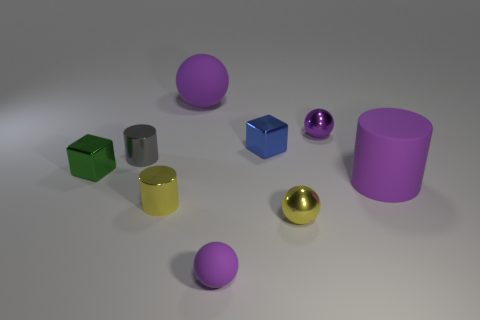Are there more tiny purple balls behind the yellow ball than small blue rubber cylinders?
Your answer should be compact. Yes. Is there another tiny metal object of the same shape as the gray metallic thing?
Make the answer very short. Yes. Do the blue object and the tiny cube on the left side of the big purple rubber sphere have the same material?
Make the answer very short. Yes. The tiny rubber object has what color?
Your response must be concise. Purple. How many small metal cylinders are on the right side of the small purple ball in front of the metallic ball that is behind the big rubber cylinder?
Ensure brevity in your answer.  0. There is a rubber cylinder; are there any purple spheres left of it?
Your answer should be compact. Yes. What number of large purple balls are the same material as the purple cylinder?
Keep it short and to the point. 1. What number of objects are either yellow metallic objects or big matte objects?
Make the answer very short. 4. Are any red rubber cylinders visible?
Your answer should be very brief. No. What is the tiny yellow thing right of the purple rubber sphere to the right of the purple rubber sphere that is behind the small yellow ball made of?
Your answer should be compact. Metal. 